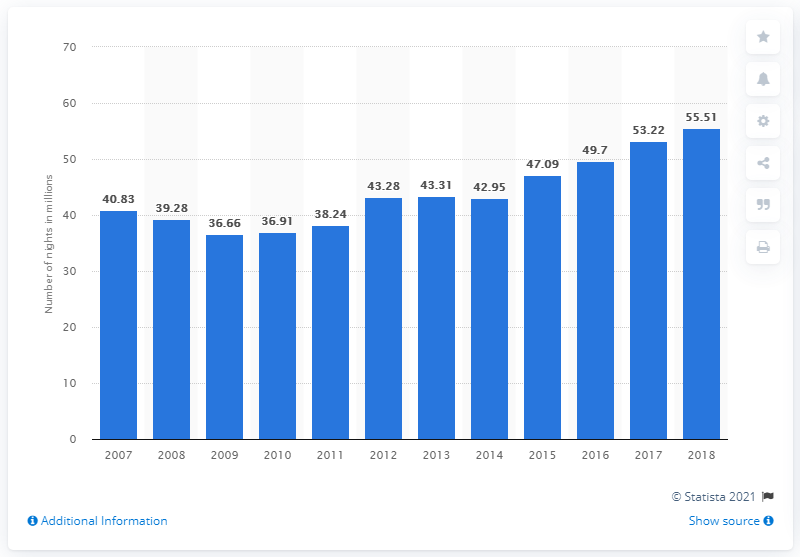Highlight a few significant elements in this photo. In 2018, a total of 55.51 nights were spent by both domestic and international tourists in the Czech Republic. 